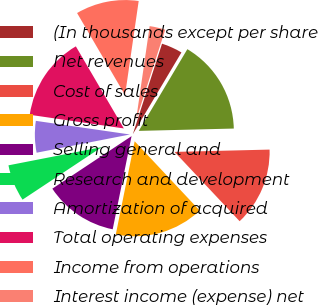<chart> <loc_0><loc_0><loc_500><loc_500><pie_chart><fcel>(In thousands except per share<fcel>Net revenues<fcel>Cost of sales<fcel>Gross profit<fcel>Selling general and<fcel>Research and development<fcel>Amortization of acquired<fcel>Total operating expenses<fcel>Income from operations<fcel>Interest income (expense) net<nl><fcel>3.57%<fcel>16.07%<fcel>13.39%<fcel>15.18%<fcel>12.5%<fcel>6.25%<fcel>5.36%<fcel>14.29%<fcel>10.71%<fcel>2.68%<nl></chart> 